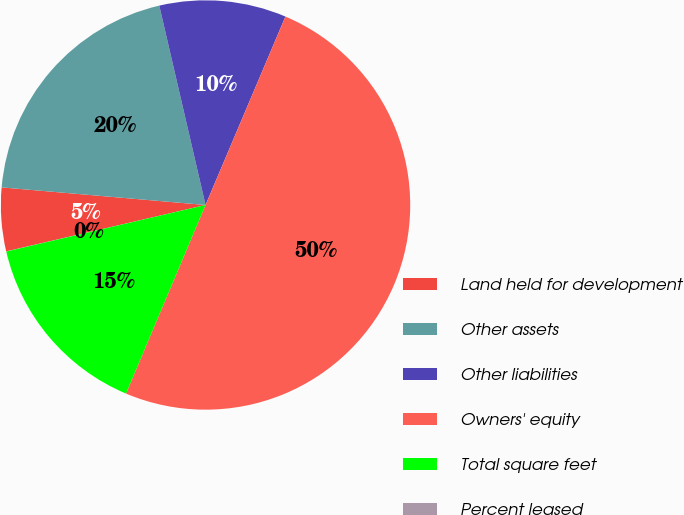Convert chart. <chart><loc_0><loc_0><loc_500><loc_500><pie_chart><fcel>Land held for development<fcel>Other assets<fcel>Other liabilities<fcel>Owners' equity<fcel>Total square feet<fcel>Percent leased<nl><fcel>5.01%<fcel>20.0%<fcel>10.01%<fcel>49.97%<fcel>15.0%<fcel>0.01%<nl></chart> 